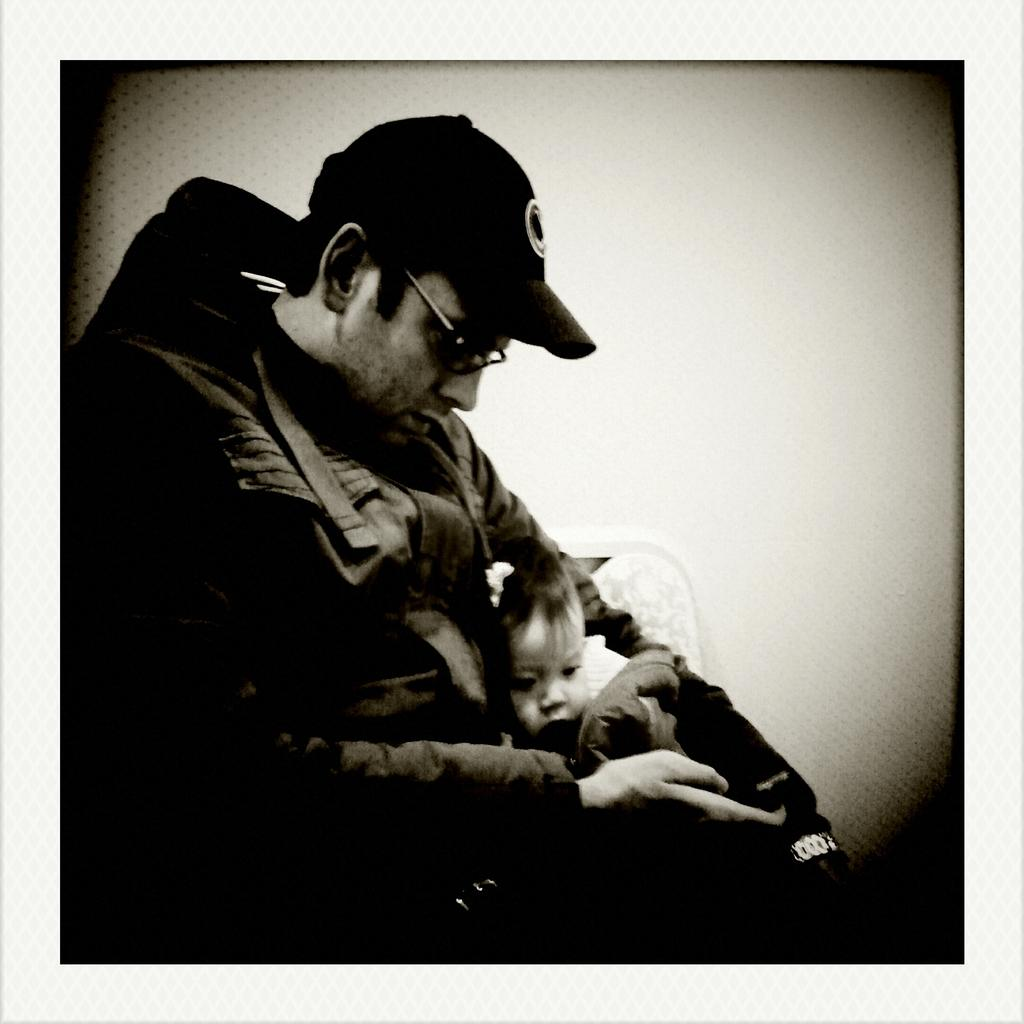Who is present in the image? There is a man in the picture. What is the man wearing on his head? The man is wearing a cap. What is the man holding in the image? The man is holding a baby. What is the color scheme of the image? The picture is in black and white. What type of winter clothing is the man wearing in the image? The image is in black and white, and there is no specific mention of winter clothing. Additionally, the man is wearing a cap, but it is not specified as winter clothing. 